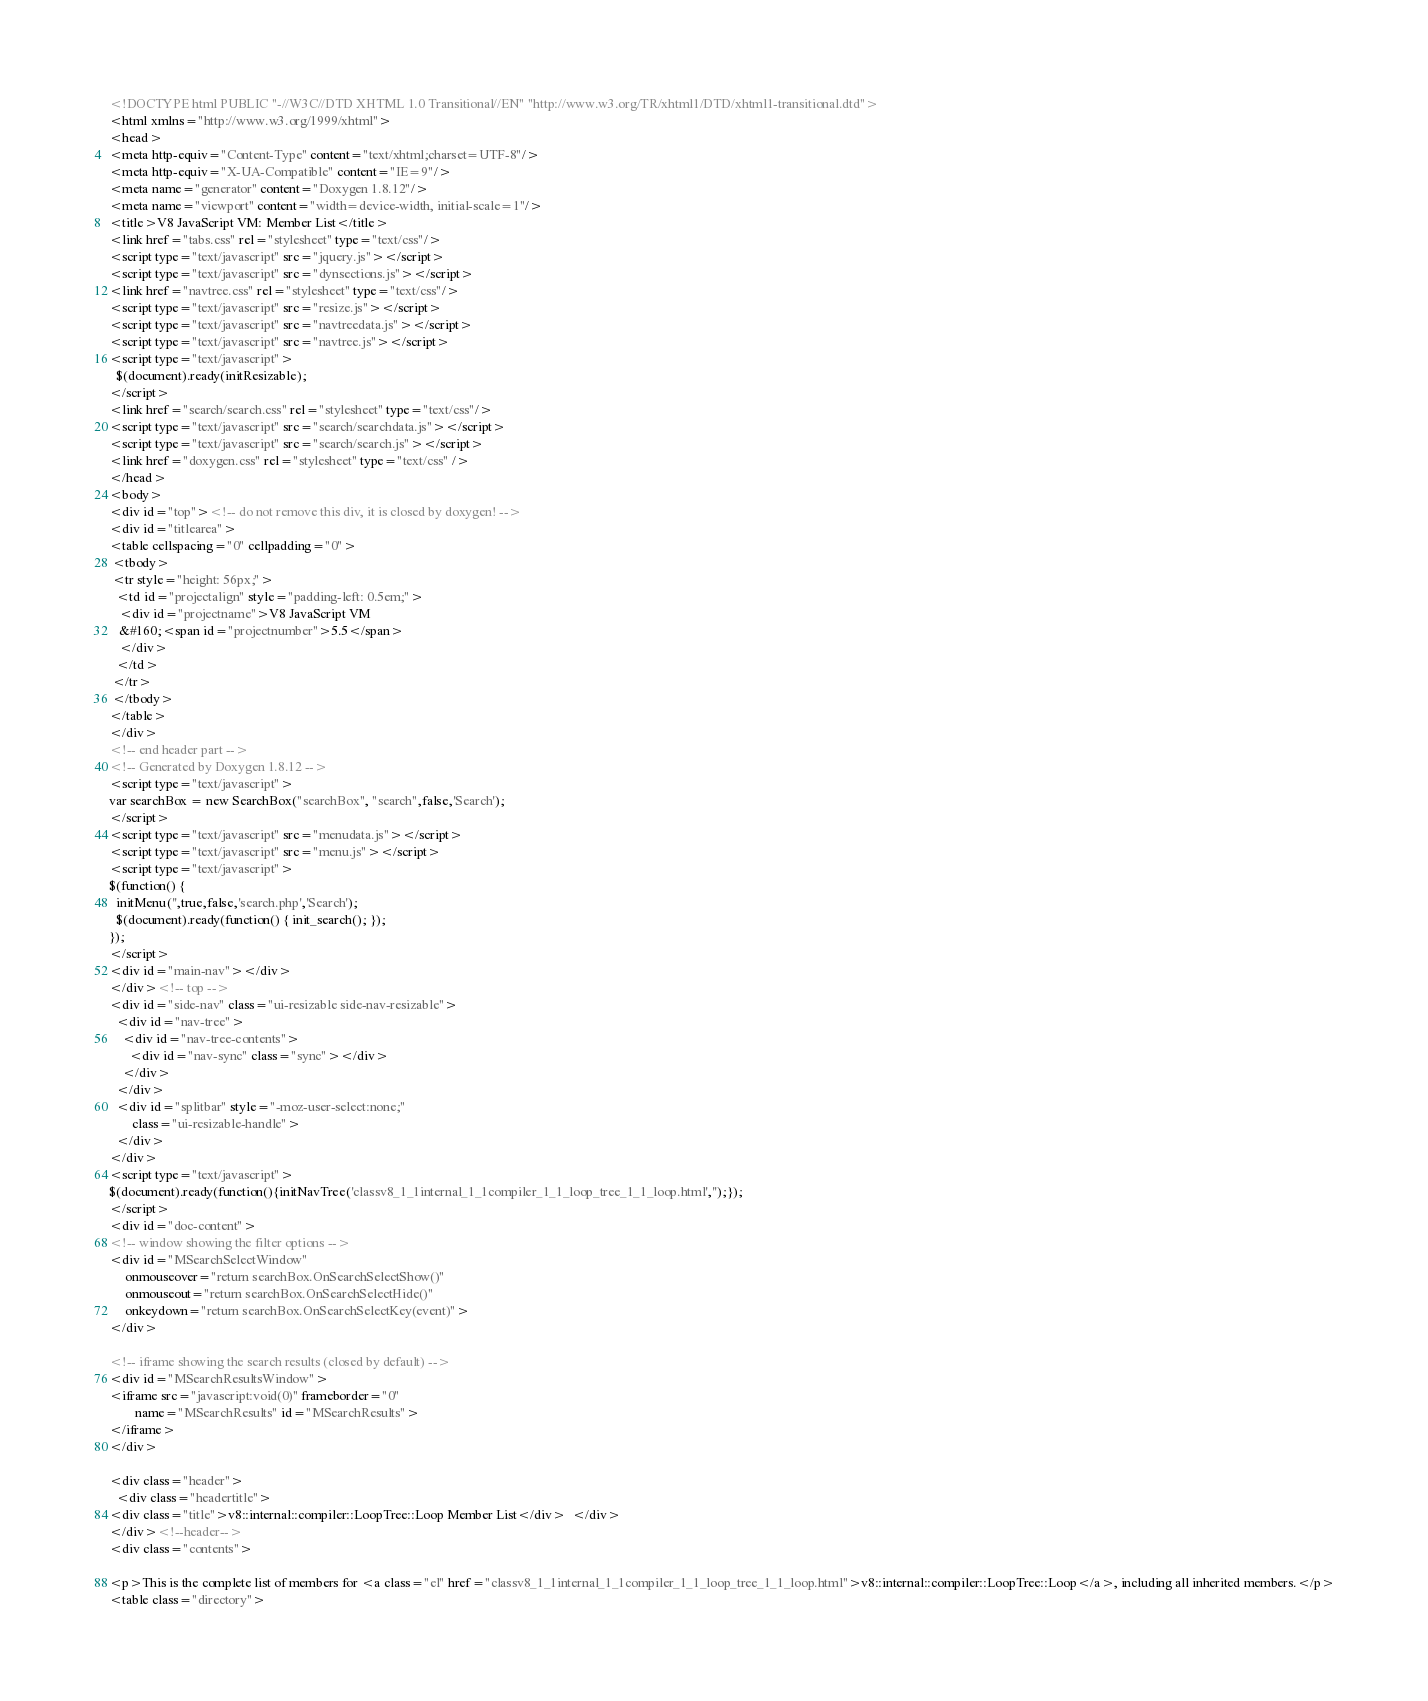Convert code to text. <code><loc_0><loc_0><loc_500><loc_500><_HTML_><!DOCTYPE html PUBLIC "-//W3C//DTD XHTML 1.0 Transitional//EN" "http://www.w3.org/TR/xhtml1/DTD/xhtml1-transitional.dtd">
<html xmlns="http://www.w3.org/1999/xhtml">
<head>
<meta http-equiv="Content-Type" content="text/xhtml;charset=UTF-8"/>
<meta http-equiv="X-UA-Compatible" content="IE=9"/>
<meta name="generator" content="Doxygen 1.8.12"/>
<meta name="viewport" content="width=device-width, initial-scale=1"/>
<title>V8 JavaScript VM: Member List</title>
<link href="tabs.css" rel="stylesheet" type="text/css"/>
<script type="text/javascript" src="jquery.js"></script>
<script type="text/javascript" src="dynsections.js"></script>
<link href="navtree.css" rel="stylesheet" type="text/css"/>
<script type="text/javascript" src="resize.js"></script>
<script type="text/javascript" src="navtreedata.js"></script>
<script type="text/javascript" src="navtree.js"></script>
<script type="text/javascript">
  $(document).ready(initResizable);
</script>
<link href="search/search.css" rel="stylesheet" type="text/css"/>
<script type="text/javascript" src="search/searchdata.js"></script>
<script type="text/javascript" src="search/search.js"></script>
<link href="doxygen.css" rel="stylesheet" type="text/css" />
</head>
<body>
<div id="top"><!-- do not remove this div, it is closed by doxygen! -->
<div id="titlearea">
<table cellspacing="0" cellpadding="0">
 <tbody>
 <tr style="height: 56px;">
  <td id="projectalign" style="padding-left: 0.5em;">
   <div id="projectname">V8 JavaScript VM
   &#160;<span id="projectnumber">5.5</span>
   </div>
  </td>
 </tr>
 </tbody>
</table>
</div>
<!-- end header part -->
<!-- Generated by Doxygen 1.8.12 -->
<script type="text/javascript">
var searchBox = new SearchBox("searchBox", "search",false,'Search');
</script>
<script type="text/javascript" src="menudata.js"></script>
<script type="text/javascript" src="menu.js"></script>
<script type="text/javascript">
$(function() {
  initMenu('',true,false,'search.php','Search');
  $(document).ready(function() { init_search(); });
});
</script>
<div id="main-nav"></div>
</div><!-- top -->
<div id="side-nav" class="ui-resizable side-nav-resizable">
  <div id="nav-tree">
    <div id="nav-tree-contents">
      <div id="nav-sync" class="sync"></div>
    </div>
  </div>
  <div id="splitbar" style="-moz-user-select:none;" 
       class="ui-resizable-handle">
  </div>
</div>
<script type="text/javascript">
$(document).ready(function(){initNavTree('classv8_1_1internal_1_1compiler_1_1_loop_tree_1_1_loop.html','');});
</script>
<div id="doc-content">
<!-- window showing the filter options -->
<div id="MSearchSelectWindow"
     onmouseover="return searchBox.OnSearchSelectShow()"
     onmouseout="return searchBox.OnSearchSelectHide()"
     onkeydown="return searchBox.OnSearchSelectKey(event)">
</div>

<!-- iframe showing the search results (closed by default) -->
<div id="MSearchResultsWindow">
<iframe src="javascript:void(0)" frameborder="0" 
        name="MSearchResults" id="MSearchResults">
</iframe>
</div>

<div class="header">
  <div class="headertitle">
<div class="title">v8::internal::compiler::LoopTree::Loop Member List</div>  </div>
</div><!--header-->
<div class="contents">

<p>This is the complete list of members for <a class="el" href="classv8_1_1internal_1_1compiler_1_1_loop_tree_1_1_loop.html">v8::internal::compiler::LoopTree::Loop</a>, including all inherited members.</p>
<table class="directory"></code> 